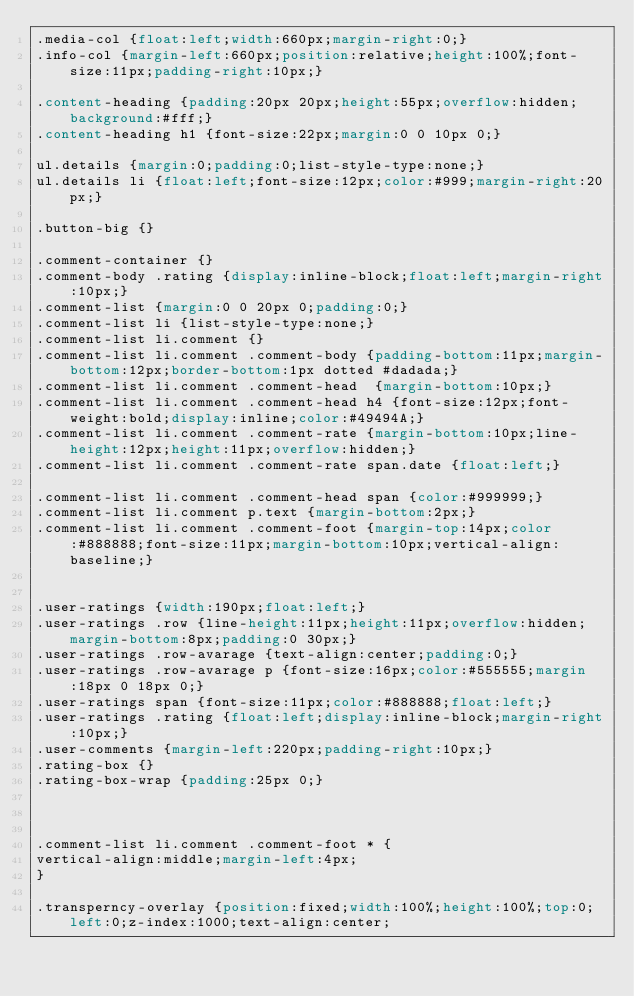Convert code to text. <code><loc_0><loc_0><loc_500><loc_500><_CSS_>.media-col {float:left;width:660px;margin-right:0;}
.info-col {margin-left:660px;position:relative;height:100%;font-size:11px;padding-right:10px;}

.content-heading {padding:20px 20px;height:55px;overflow:hidden;background:#fff;}
.content-heading h1 {font-size:22px;margin:0 0 10px 0;}

ul.details {margin:0;padding:0;list-style-type:none;}
ul.details li {float:left;font-size:12px;color:#999;margin-right:20px;}

.button-big {}

.comment-container {}
.comment-body .rating {display:inline-block;float:left;margin-right:10px;}
.comment-list {margin:0 0 20px 0;padding:0;}
.comment-list li {list-style-type:none;}
.comment-list li.comment {}
.comment-list li.comment .comment-body {padding-bottom:11px;margin-bottom:12px;border-bottom:1px dotted #dadada;}
.comment-list li.comment .comment-head  {margin-bottom:10px;}
.comment-list li.comment .comment-head h4 {font-size:12px;font-weight:bold;display:inline;color:#49494A;}
.comment-list li.comment .comment-rate {margin-bottom:10px;line-height:12px;height:11px;overflow:hidden;}
.comment-list li.comment .comment-rate span.date {float:left;}

.comment-list li.comment .comment-head span {color:#999999;}
.comment-list li.comment p.text {margin-bottom:2px;}
.comment-list li.comment .comment-foot {margin-top:14px;color:#888888;font-size:11px;margin-bottom:10px;vertical-align:baseline;}


.user-ratings {width:190px;float:left;}
.user-ratings .row {line-height:11px;height:11px;overflow:hidden;margin-bottom:8px;padding:0 30px;}
.user-ratings .row-avarage {text-align:center;padding:0;}
.user-ratings .row-avarage p {font-size:16px;color:#555555;margin:18px 0 18px 0;}
.user-ratings span {font-size:11px;color:#888888;float:left;}
.user-ratings .rating {float:left;display:inline-block;margin-right:10px;}
.user-comments {margin-left:220px;padding-right:10px;}
.rating-box {}
.rating-box-wrap {padding:25px 0;}		



.comment-list li.comment .comment-foot * {
vertical-align:middle;margin-left:4px;
}

.transperncy-overlay {position:fixed;width:100%;height:100%;top:0;left:0;z-index:1000;text-align:center;</code> 